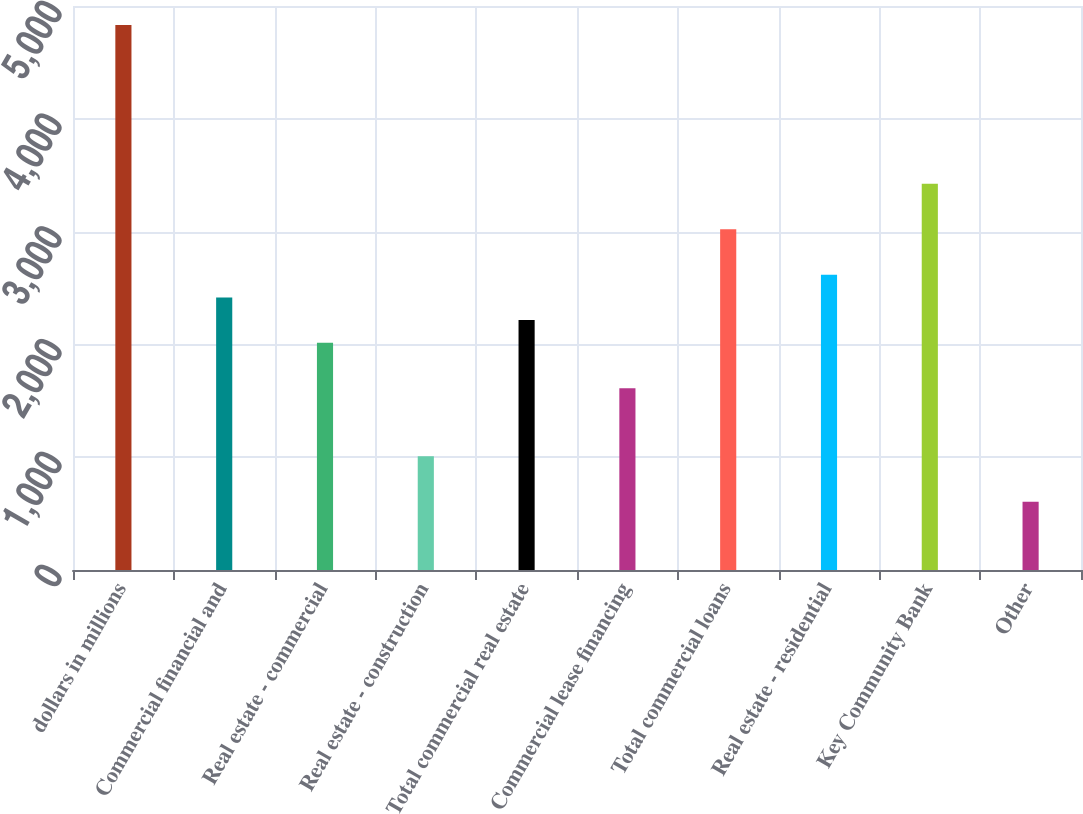Convert chart. <chart><loc_0><loc_0><loc_500><loc_500><bar_chart><fcel>dollars in millions<fcel>Commercial financial and<fcel>Real estate - commercial<fcel>Real estate - construction<fcel>Total commercial real estate<fcel>Commercial lease financing<fcel>Total commercial loans<fcel>Real estate - residential<fcel>Key Community Bank<fcel>Other<nl><fcel>4832.65<fcel>2416.69<fcel>2014.03<fcel>1007.38<fcel>2215.36<fcel>1611.37<fcel>3020.68<fcel>2618.02<fcel>3423.34<fcel>604.72<nl></chart> 